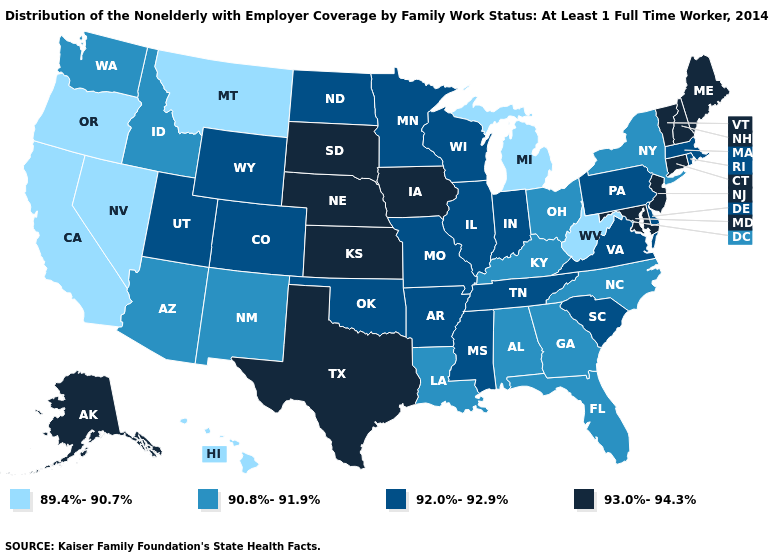What is the value of Alabama?
Concise answer only. 90.8%-91.9%. How many symbols are there in the legend?
Be succinct. 4. What is the value of Washington?
Write a very short answer. 90.8%-91.9%. Which states have the lowest value in the MidWest?
Give a very brief answer. Michigan. Among the states that border Ohio , which have the highest value?
Quick response, please. Indiana, Pennsylvania. Does California have the lowest value in the West?
Answer briefly. Yes. How many symbols are there in the legend?
Quick response, please. 4. What is the value of South Carolina?
Quick response, please. 92.0%-92.9%. What is the value of North Carolina?
Short answer required. 90.8%-91.9%. Does Connecticut have a higher value than Vermont?
Give a very brief answer. No. Name the states that have a value in the range 89.4%-90.7%?
Answer briefly. California, Hawaii, Michigan, Montana, Nevada, Oregon, West Virginia. Which states have the lowest value in the USA?
Concise answer only. California, Hawaii, Michigan, Montana, Nevada, Oregon, West Virginia. Does the first symbol in the legend represent the smallest category?
Answer briefly. Yes. What is the value of Nebraska?
Concise answer only. 93.0%-94.3%. What is the value of Missouri?
Answer briefly. 92.0%-92.9%. 